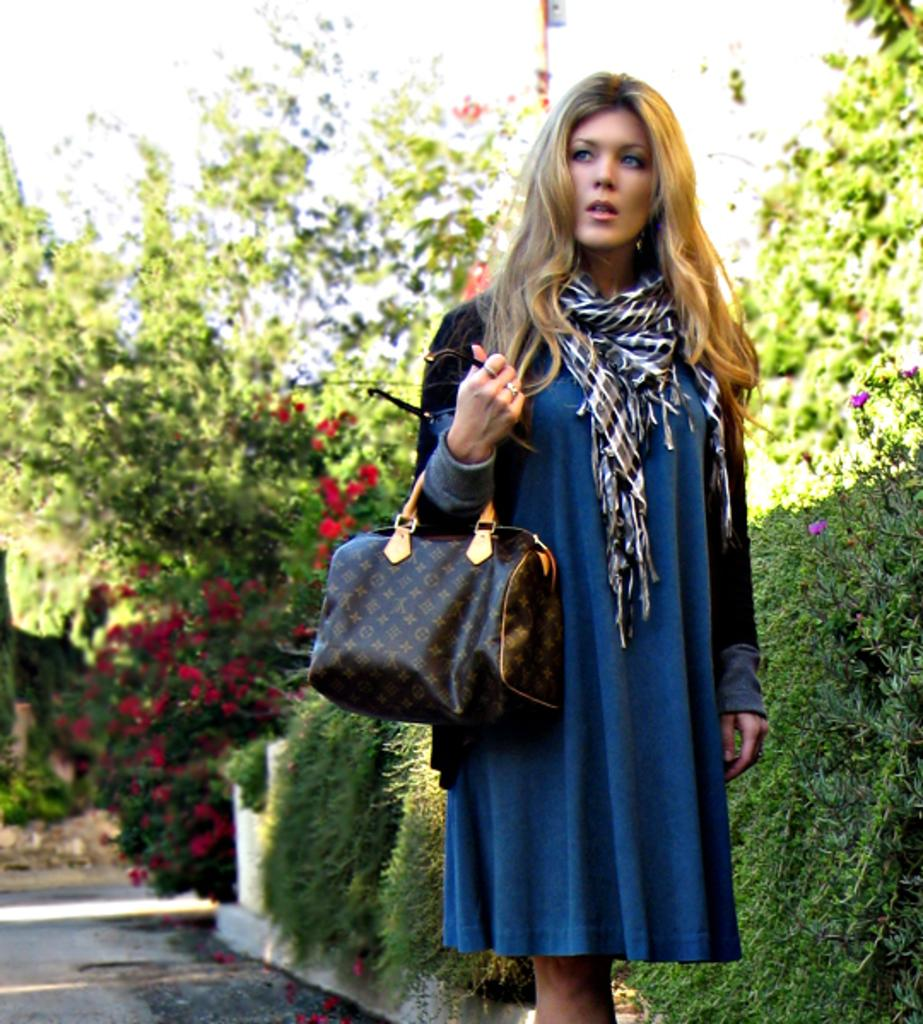Who is present in the image? There is a person in the image. What is the person wearing? The person is wearing a blue dress and shrug. What is the person holding or carrying in the image? The person is carrying a bag. What can be seen in the background of the image? There are trees in the background of the image. What type of silk is being displayed in the image? There is no silk present in the image. How does the person show their emotions in the image? The image does not show the person's emotions, as it only captures their appearance and what they are carrying. 